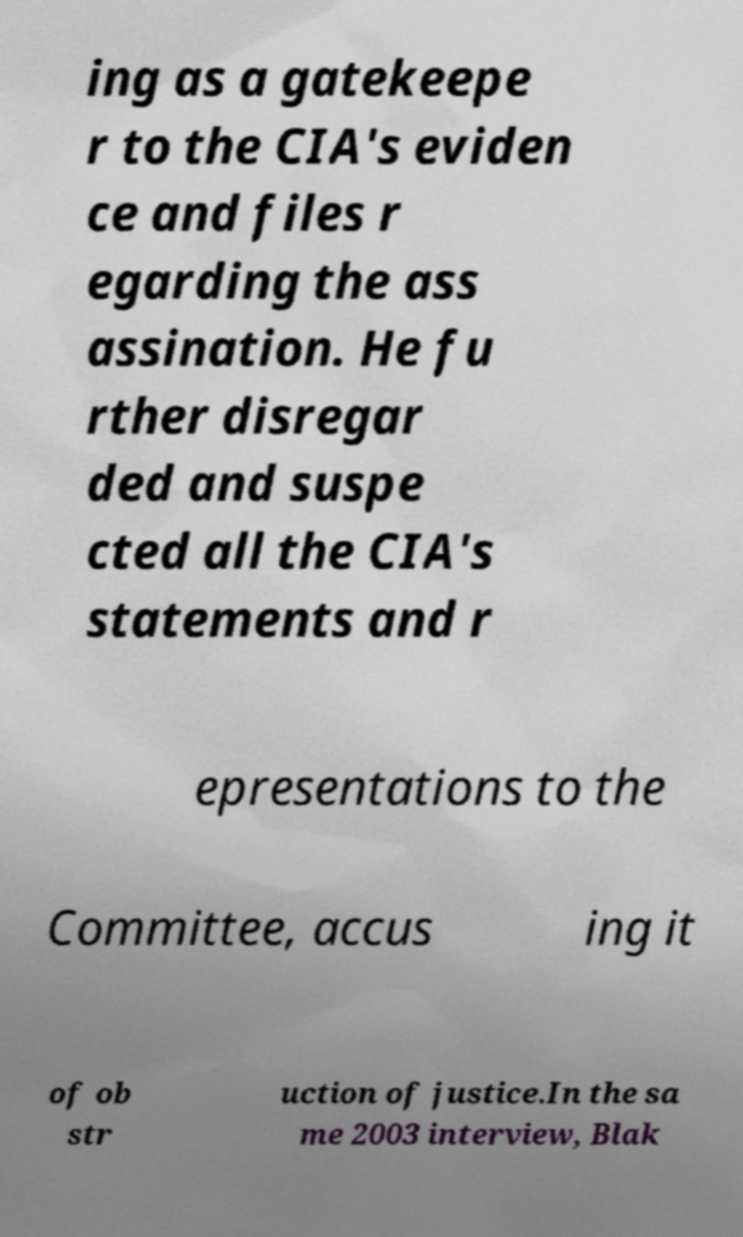Can you accurately transcribe the text from the provided image for me? ing as a gatekeepe r to the CIA's eviden ce and files r egarding the ass assination. He fu rther disregar ded and suspe cted all the CIA's statements and r epresentations to the Committee, accus ing it of ob str uction of justice.In the sa me 2003 interview, Blak 